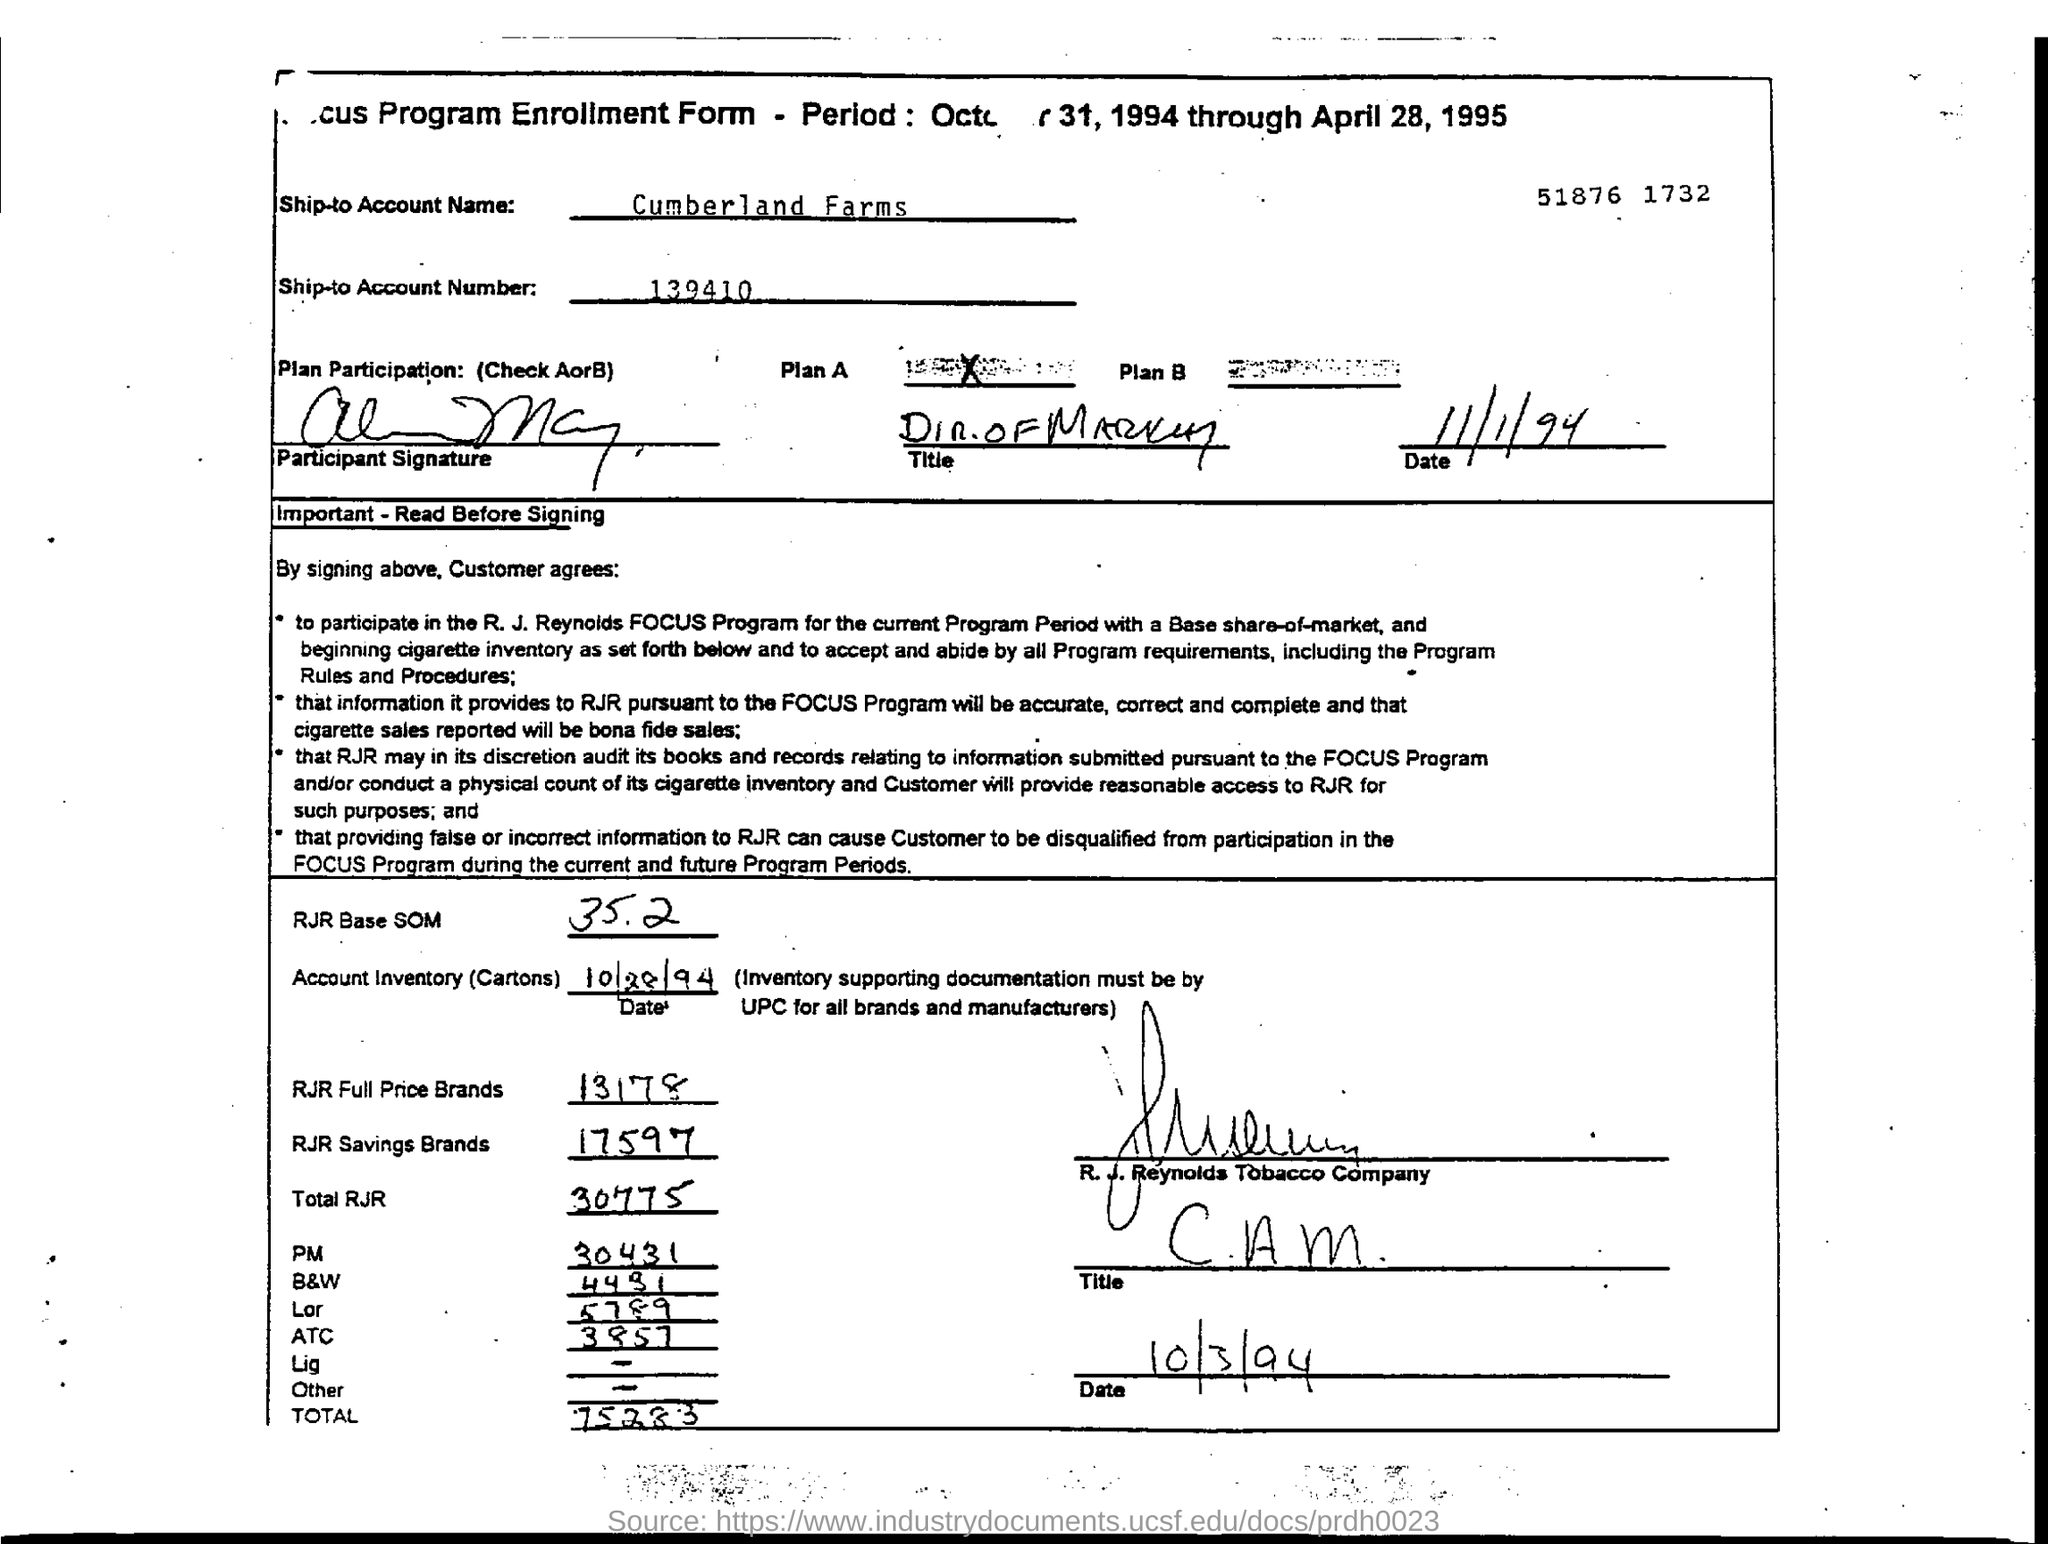What is the ship-to account name given in the form?
Provide a succinct answer. Cumberland Farms. What is the ship-to account number mentioned in the form?
Provide a succinct answer. 139410. What is the RJR Base SOM mentioned in the form?
Make the answer very short. 35.2. 